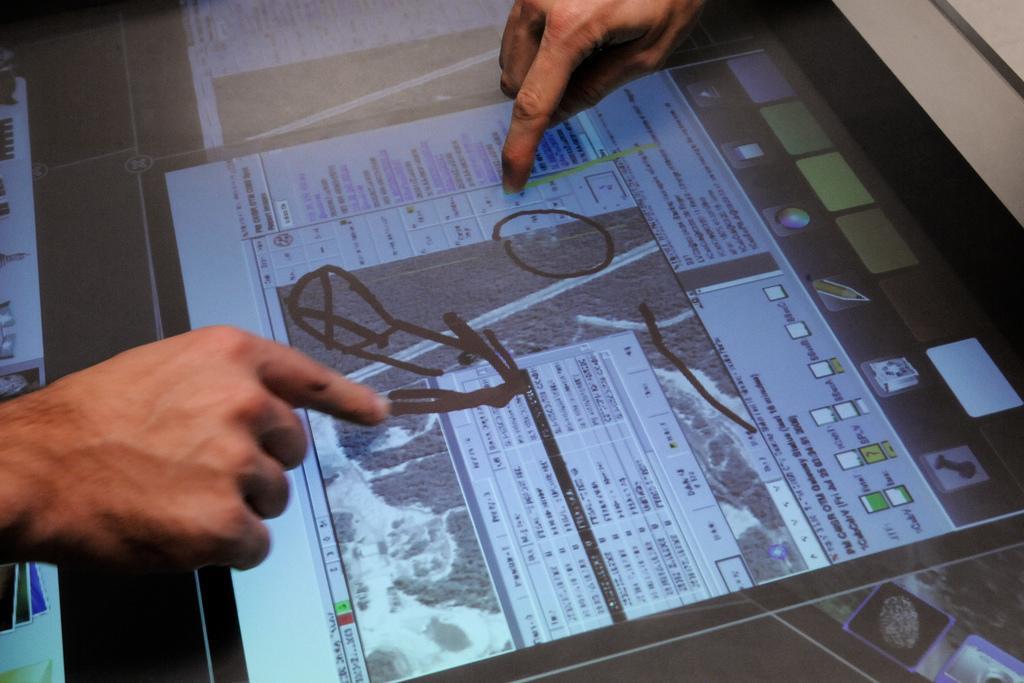In one or two sentences, can you explain what this image depicts? In the picture we can see an iPad on the desk and some persons hands on it marking something on it. 